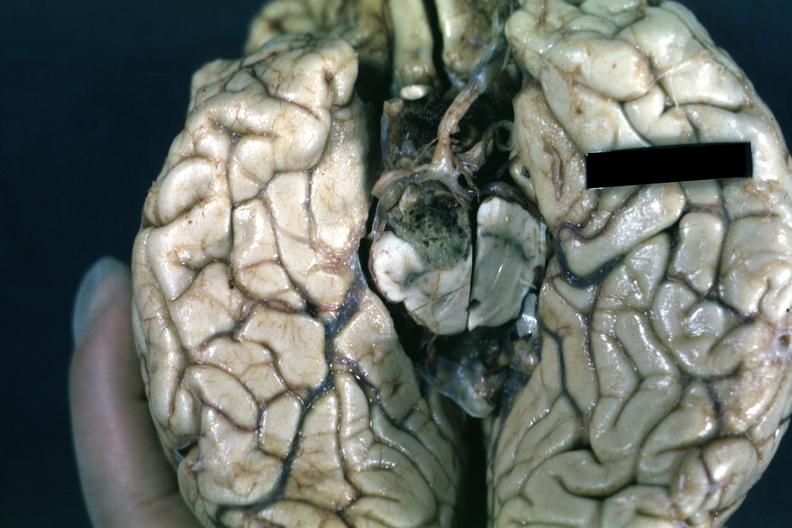what is present?
Answer the question using a single word or phrase. Chromophobe adenoma 